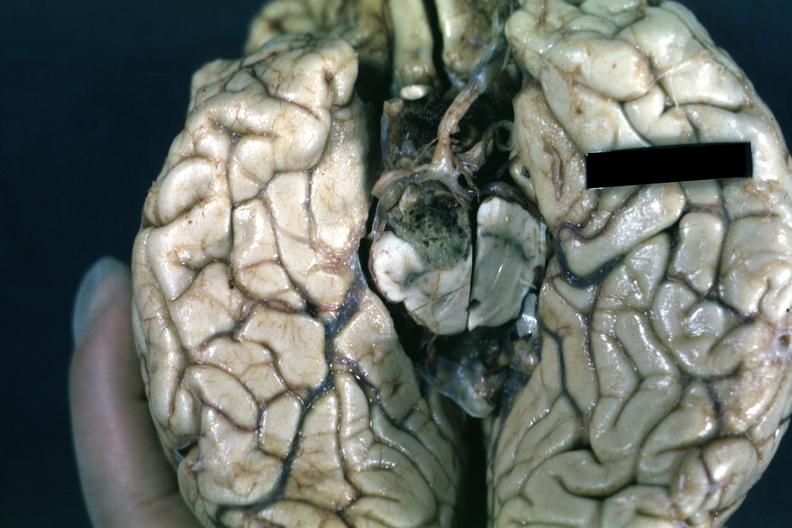what is present?
Answer the question using a single word or phrase. Chromophobe adenoma 